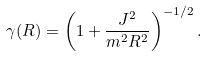<formula> <loc_0><loc_0><loc_500><loc_500>\gamma ( R ) = \left ( 1 + \frac { J ^ { 2 } } { m ^ { 2 } R ^ { 2 } } \right ) ^ { - 1 / 2 } .</formula> 